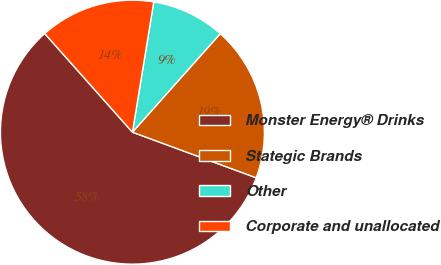Convert chart to OTSL. <chart><loc_0><loc_0><loc_500><loc_500><pie_chart><fcel>Monster Energy® Drinks<fcel>Stategic Brands<fcel>Other<fcel>Corporate and unallocated<nl><fcel>57.81%<fcel>19.03%<fcel>9.0%<fcel>14.15%<nl></chart> 